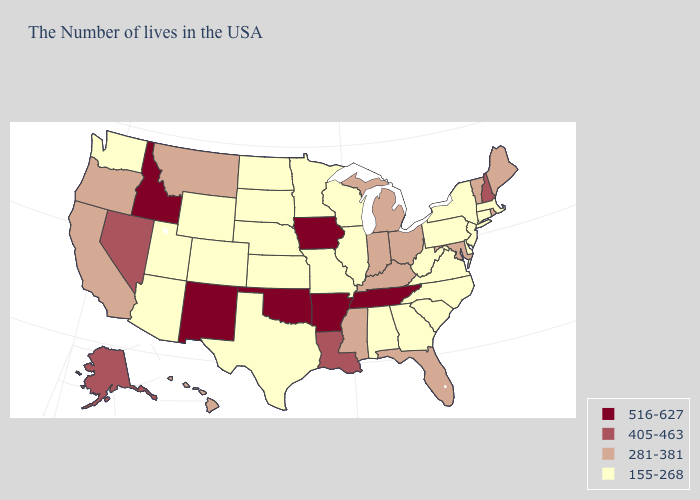Does North Dakota have the lowest value in the USA?
Quick response, please. Yes. What is the highest value in states that border Connecticut?
Keep it brief. 281-381. Name the states that have a value in the range 516-627?
Quick response, please. Tennessee, Arkansas, Iowa, Oklahoma, New Mexico, Idaho. What is the value of Louisiana?
Concise answer only. 405-463. Does Colorado have a higher value than Massachusetts?
Answer briefly. No. Among the states that border Kentucky , which have the highest value?
Short answer required. Tennessee. What is the value of Alabama?
Concise answer only. 155-268. Does Massachusetts have the lowest value in the Northeast?
Give a very brief answer. Yes. How many symbols are there in the legend?
Quick response, please. 4. Name the states that have a value in the range 281-381?
Write a very short answer. Maine, Rhode Island, Vermont, Maryland, Ohio, Florida, Michigan, Kentucky, Indiana, Mississippi, Montana, California, Oregon, Hawaii. What is the value of Arizona?
Short answer required. 155-268. Which states have the highest value in the USA?
Give a very brief answer. Tennessee, Arkansas, Iowa, Oklahoma, New Mexico, Idaho. How many symbols are there in the legend?
Concise answer only. 4. What is the value of West Virginia?
Short answer required. 155-268. Does Utah have a lower value than Florida?
Quick response, please. Yes. 